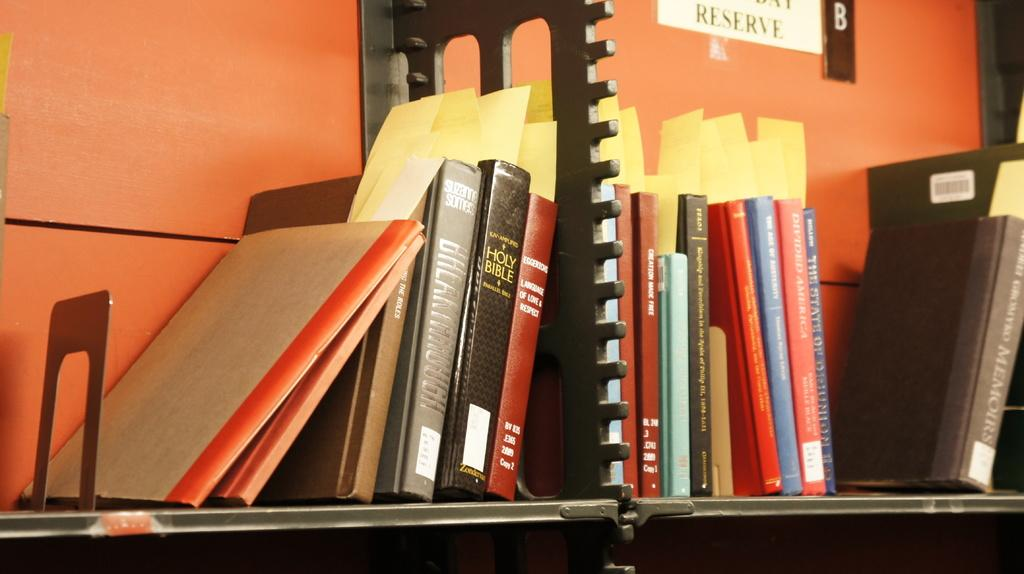<image>
Relay a brief, clear account of the picture shown. A stack of books on a cart including a KJV Holy Bible 